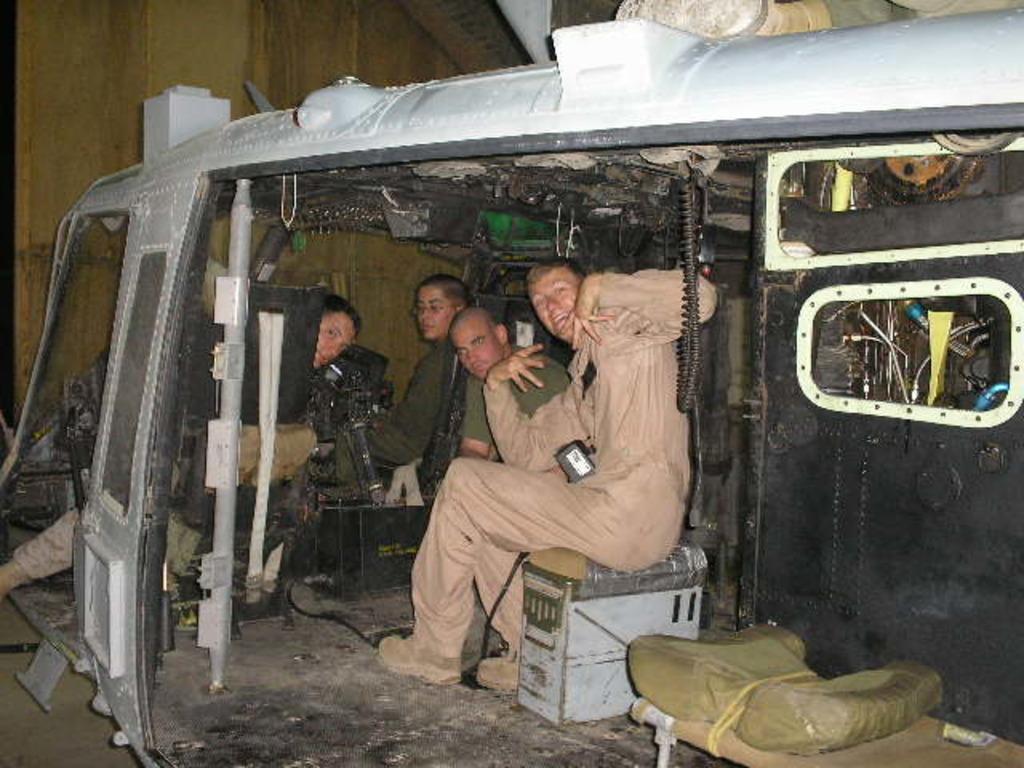Can you describe this image briefly? In this picture I can see the persons who are sitting on the table and boxes. In the bottom right I can see some plastic covers on the bed. At the top I can see the roof. They are sitting inside the plane. 